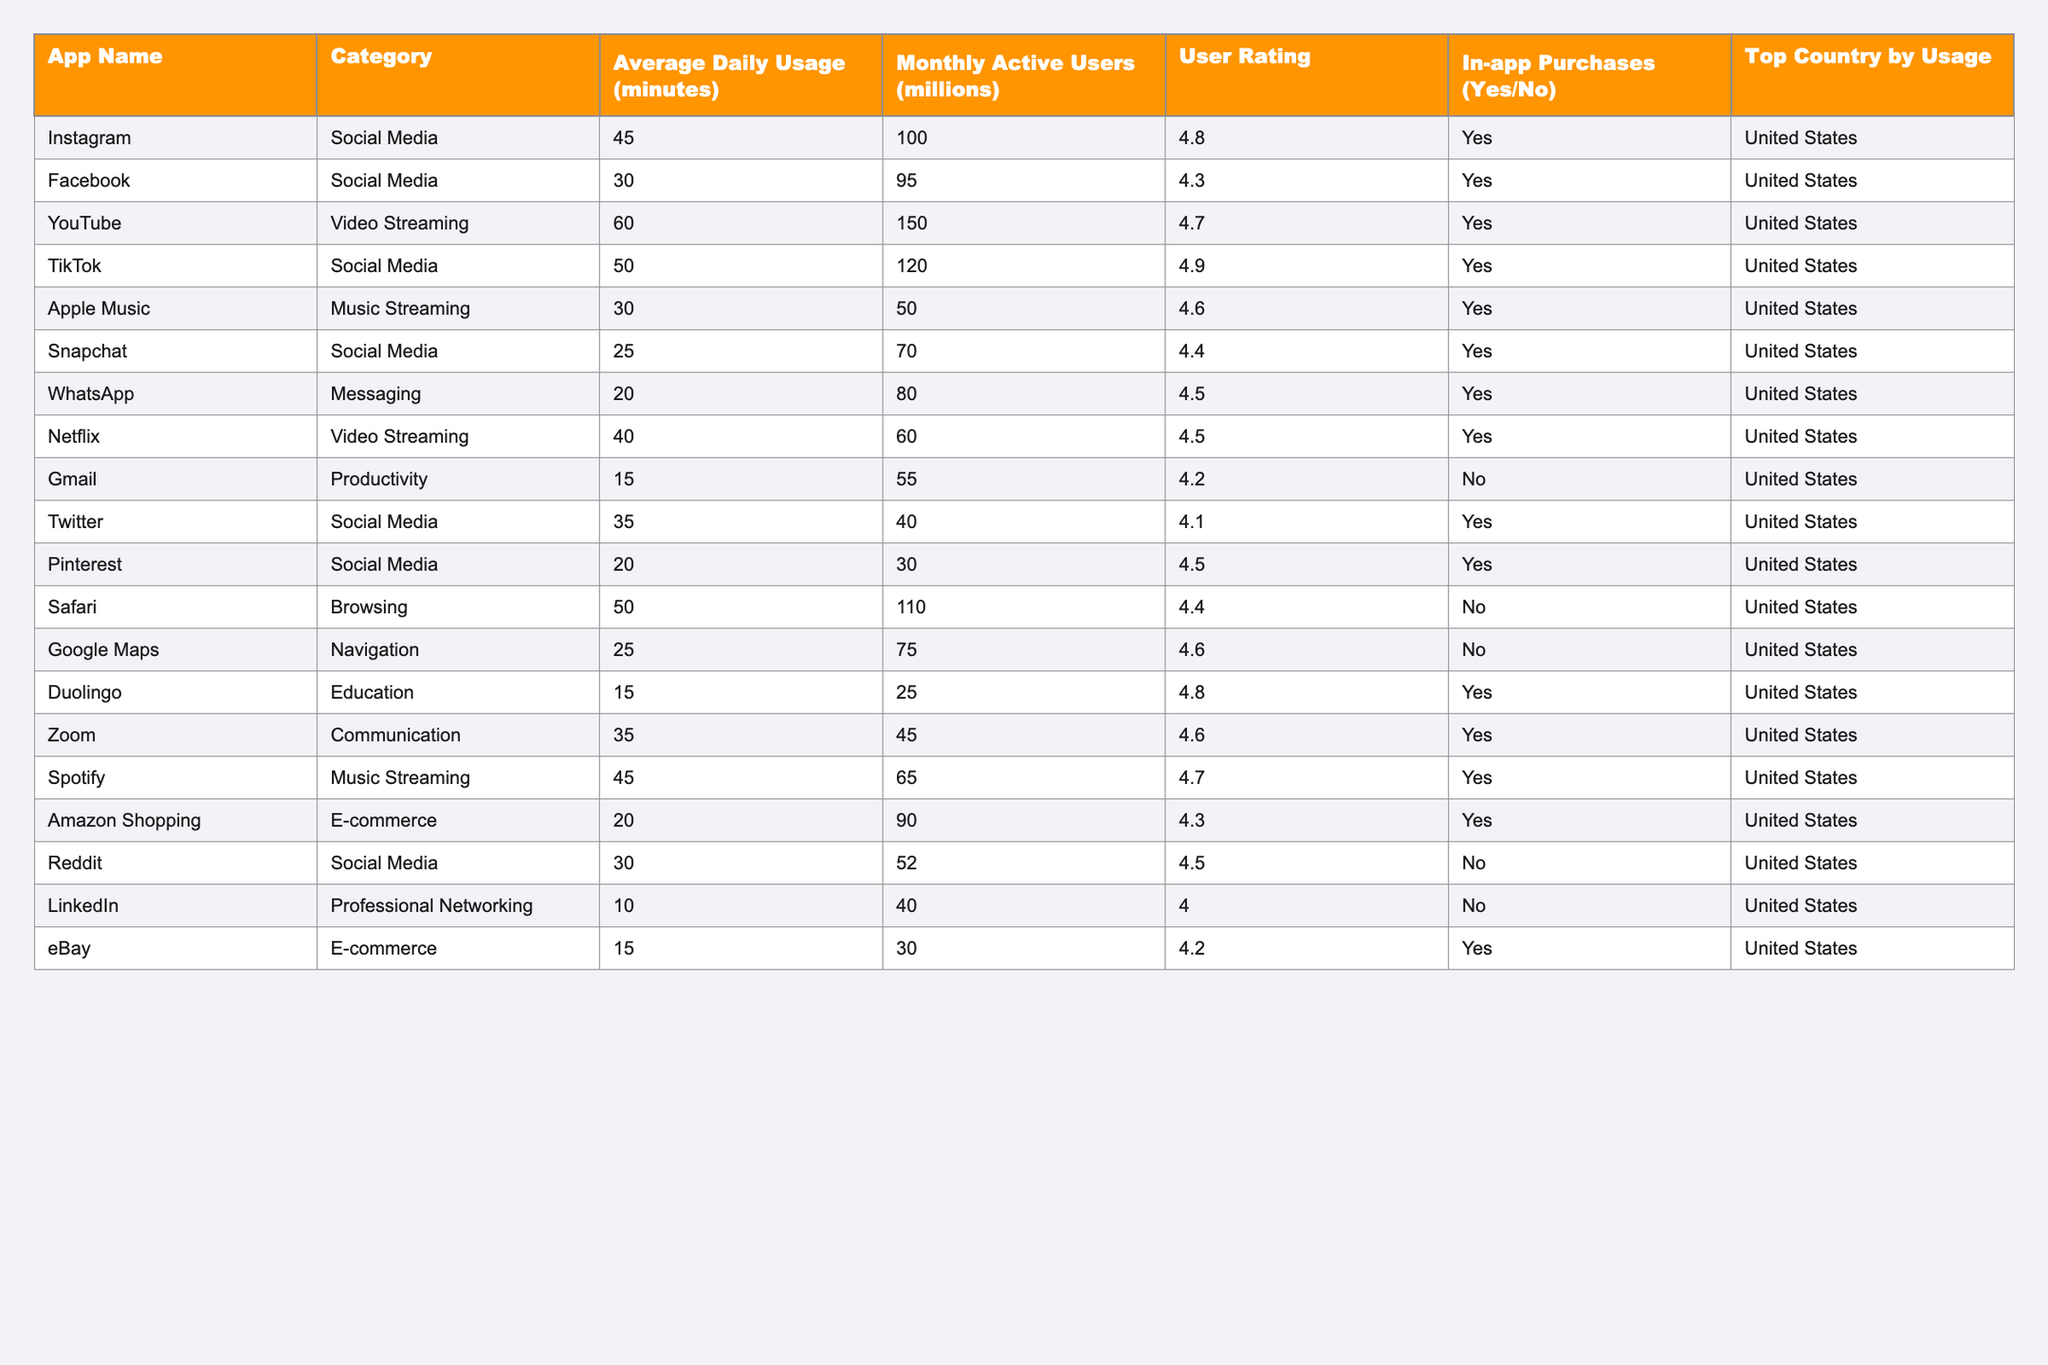What is the average daily usage of TikTok? The table shows that the average daily usage of TikTok is listed under the "Average Daily Usage (minutes)" column. Referring to the table, it can be seen that TikTok has an average daily usage of 50 minutes.
Answer: 50 minutes Which app has the highest monthly active users? By scanning through the "Monthly Active Users (millions)" column, we look for the highest value. YouTube has the highest monthly active users at 150 million.
Answer: YouTube Is WhatsApp a paid app? The table indicates whether an app has in-app purchases in the "In-app Purchases" column. Since WhatsApp shows "Yes," it means that it offers in-app purchases, suggesting it may have some monetization model.
Answer: Yes What is the combined average daily usage of Instagram and Facebook? To find the combined average usage, we look at their respective average daily usage values: Instagram has 45 minutes, and Facebook has 30 minutes. Adding them gives (45 + 30) = 75 minutes.
Answer: 75 minutes How many apps in the Social Media category have an average daily usage of over 30 minutes? We can identify and count the apps in the Social Media category that have usage over 30 minutes by examining the "Category" and "Average Daily Usage (minutes)" columns. The apps are Instagram (45), TikTok (50), and Facebook (30), giving us a total of four apps.
Answer: Four apps Which category has the lowest average daily usage overall? To ascertain this, we need to compare the average usage of each category by extracting average daily usage values from the table. After calculating, we find that the Productivity category has the lowest average usage of 15 minutes from Gmail and Duolingo.
Answer: Productivity Is Spotify rated higher than Apple Music? By examining the "User Rating" for both apps in the table, we see that Spotify has a rating of 4.7 while Apple Music has a rating of 4.6. Therefore, Spotify is rated higher than Apple Music.
Answer: Yes What is the difference in average daily usage between the highest and lowest user-rated apps? The table shows the user ratings for all apps. The highest rating is 4.9 for TikTok and the lowest is 4.0 for LinkedIn. TikTok has an average usage of 50 minutes, and LinkedIn has an average usage of 10 minutes. The difference is (50 - 10) = 40 minutes.
Answer: 40 minutes Which app has the highest user rating among the apps with in-app purchases? By filtering the "User Rating" column among apps that have "Yes" under "In-app Purchases," we find that TikTok has the highest user rating of 4.9, compared to all others.
Answer: TikTok What proportion of apps in the table have in-app purchases? To find this, count the total number of apps listed in the table (which is 20), and how many of these have "Yes" in the In-app Purchases column (which is 12). The proportion is (12 / 20) = 0.6 or 60%.
Answer: 60% Which messaging app has the highest rating? Looking at the "Messaging" category in the table, we see WhatsApp with a rating of 4.5 and no other messaging app with a rating. Thus, WhatsApp is the highest-rated messaging app.
Answer: WhatsApp 